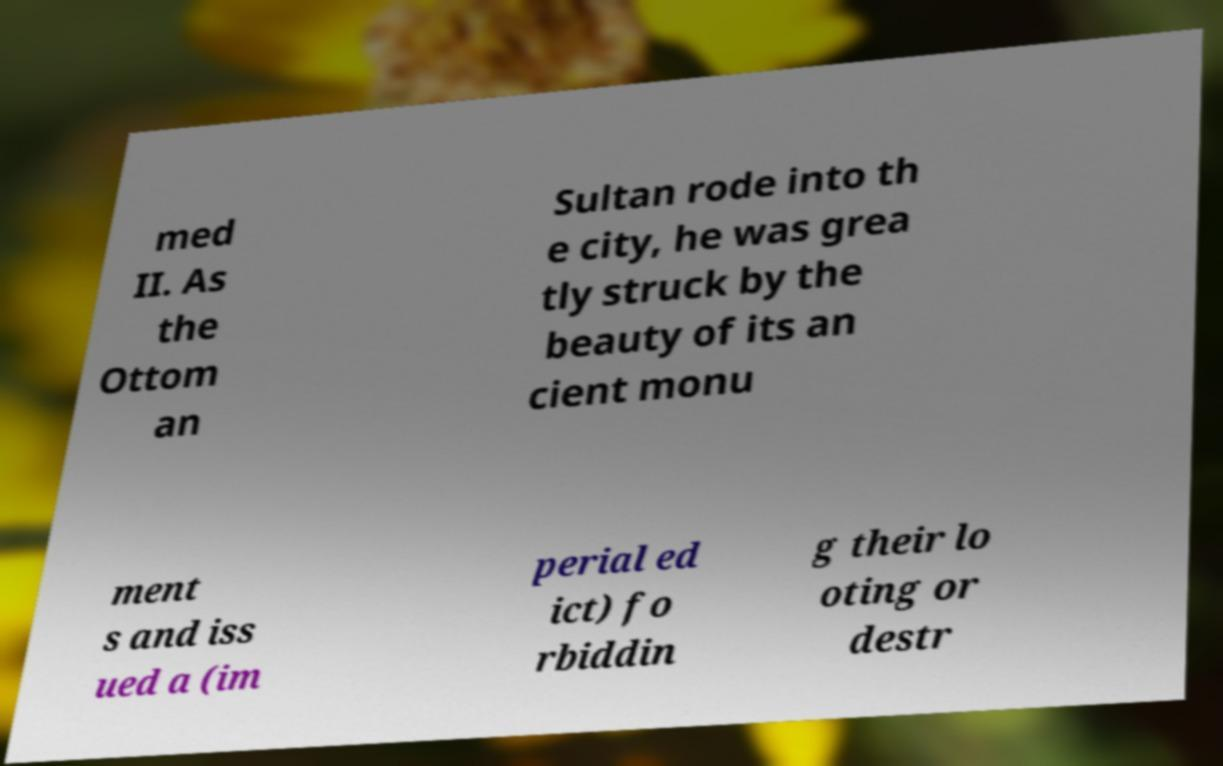Can you read and provide the text displayed in the image?This photo seems to have some interesting text. Can you extract and type it out for me? med II. As the Ottom an Sultan rode into th e city, he was grea tly struck by the beauty of its an cient monu ment s and iss ued a (im perial ed ict) fo rbiddin g their lo oting or destr 